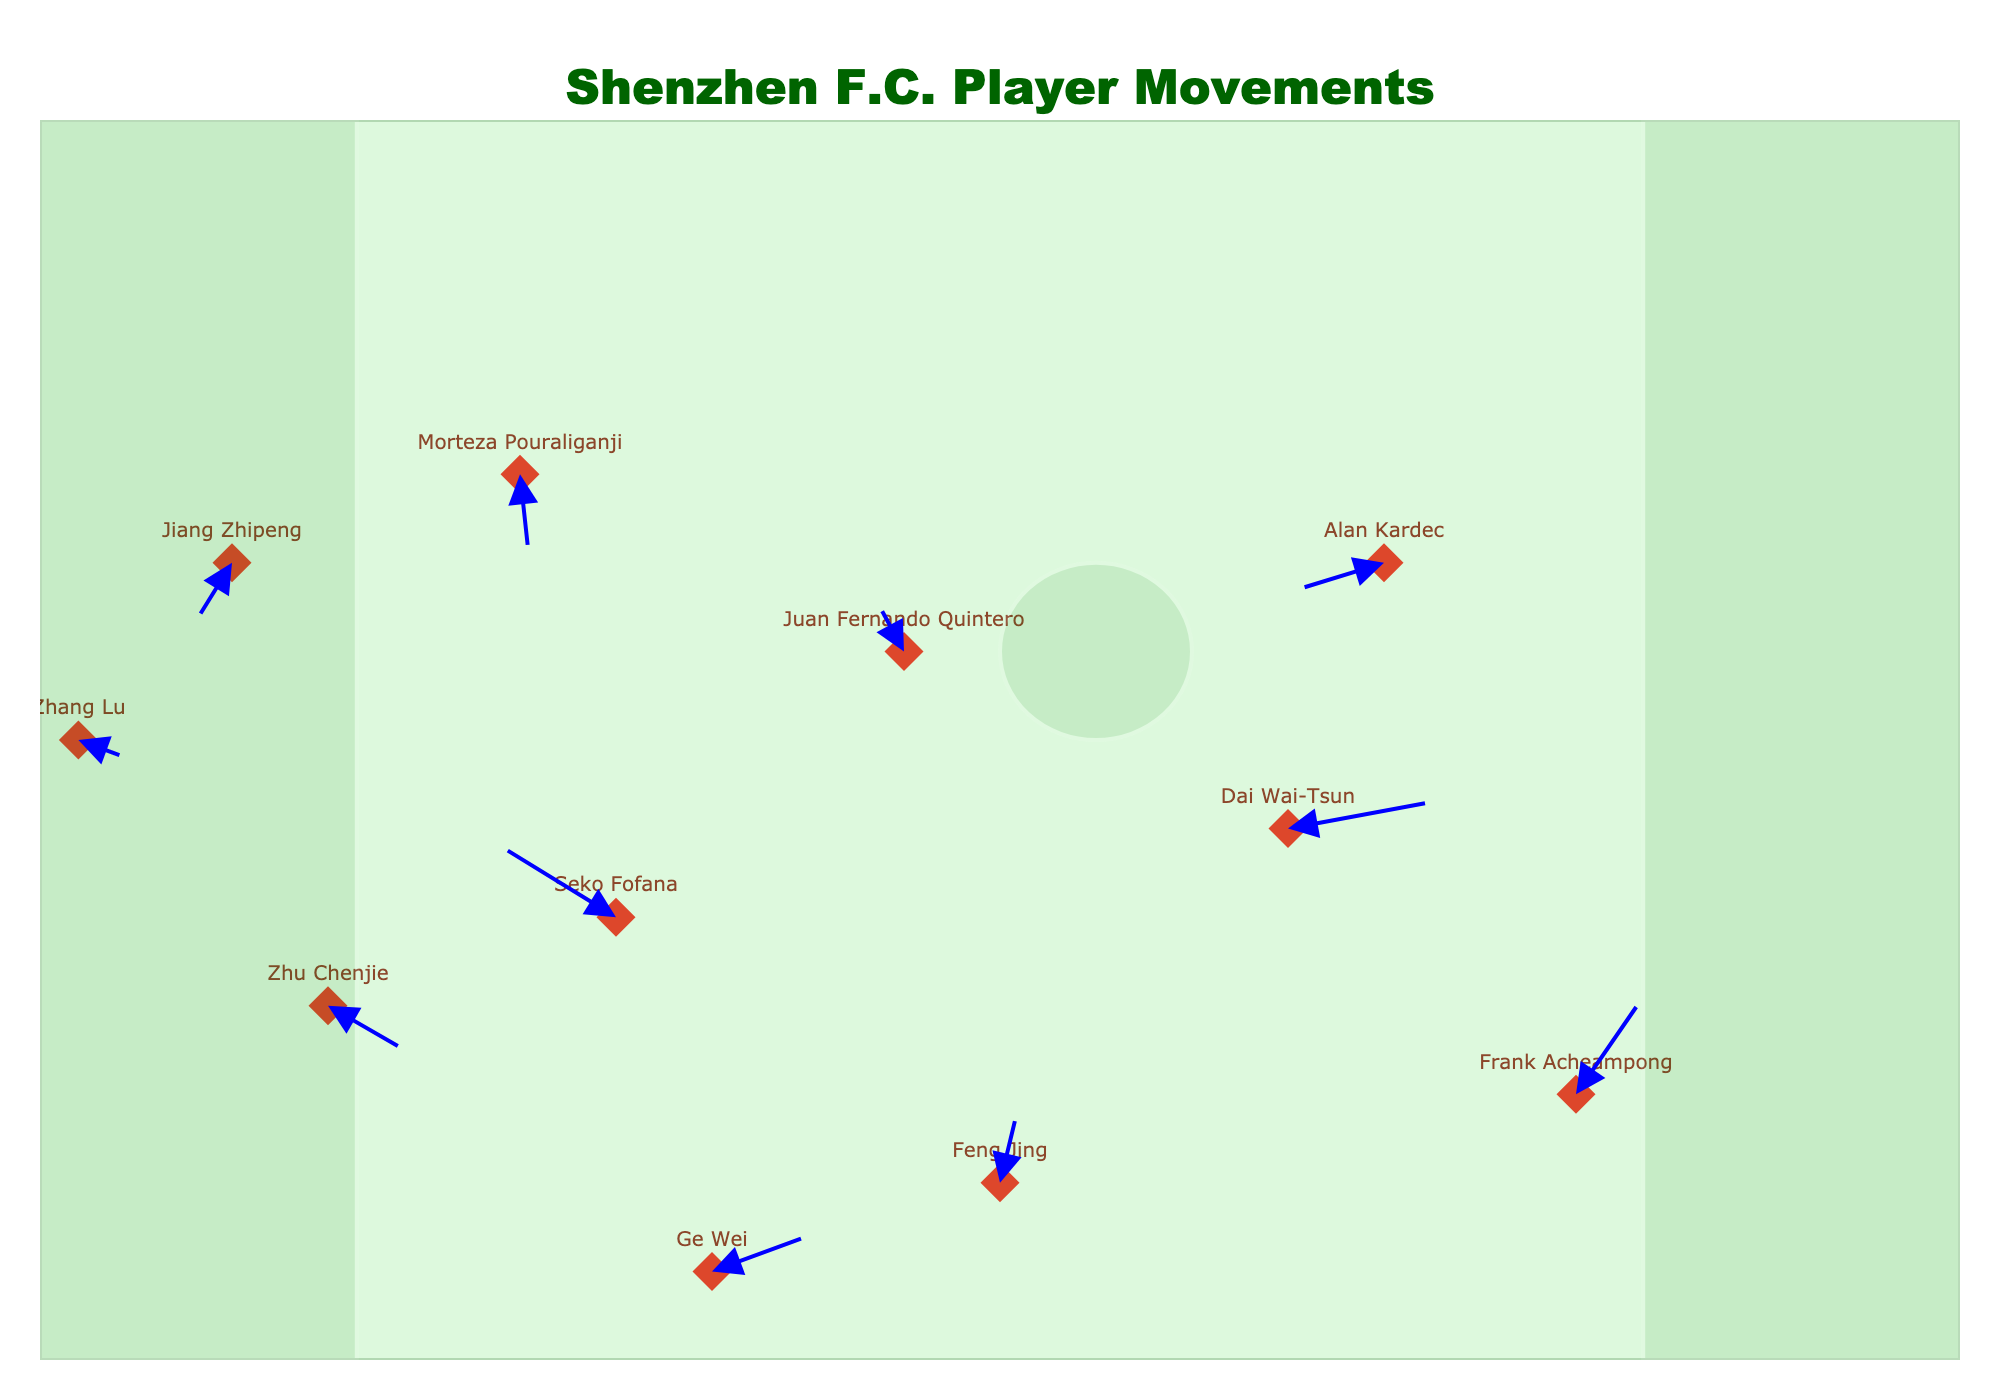Which player starts in the most advanced position on the field? The player's start position is indicated by the red diamond marker. The farthest forward position on the field is near the top of the y-axis. Frank Acheampong starts closest to the top of the y-axis at position (80, 15).
Answer: Frank Acheampong What is the average x position of all players? Add up the x positions of all players and divide the sum by the number of players: (2 + 30 + 65 + 80 + 45 + 15 + 50 + 10 + 35 + 70 + 25) / 11 = 427 / 11.
Answer: 38.82 Which player has the longest movement vector? The length of the movement vector is calculated by the Euclidean distance formula: sqrt((x_movement)^2 + (y_movement)^2). The longest vector has the largest value. Alan Kardec’s movement vector is sqrt((-0.9)^2 + (-0.3)^2) which is approximately 0.9487, the highest among all players.
Answer: Alan Kardec Who are the players involved in defensive runs based on their movement direction? Players can be considered involved in defensive runs if their movement predominantly involves a decrease in y position. These include Zhang Lu (downward movement), Jiang Zhipeng (downward movement), and Morteza Pouraliganji (downward movement).
Answer: Zhang Lu, Jiang Zhipeng, Morteza Pouraliganji How many players are making upward runs? Upward runs can be identified by positive y movement. Players with positive y movement values are Seko Fofana, Dai Wai-Tsun, Frank Acheampong, Juan Fernando Quintero, Feng Jing, and Ge Wei.
Answer: 6 Which two players have movements in opposite directions? Identify players with opposite (inversely signed) movement vectors. For instance, Jiang Zhipeng moves (-0.4, -0.7) while Dai Wai-Tsun moves (1.5, 0.3).
Answer: Jiang Zhipeng and Dai Wai-Tsun What are the average y coordinates of the offensive players (x position greater than 50)? Consider players with an x coordinate greater than 50: Dai Wai-Tsun, Frank Acheampong, Juan Fernando Quintero, Feng Jing, and Alan Kardec. Their average y is calculated as (30 + 15 + 40 + 10 + 45) / 5.
Answer: 28 Which player has the least y movement? Compare the y_movement values of each player. Zhang Lu has the smallest y movement with -0.2.
Answer: Zhang Lu 